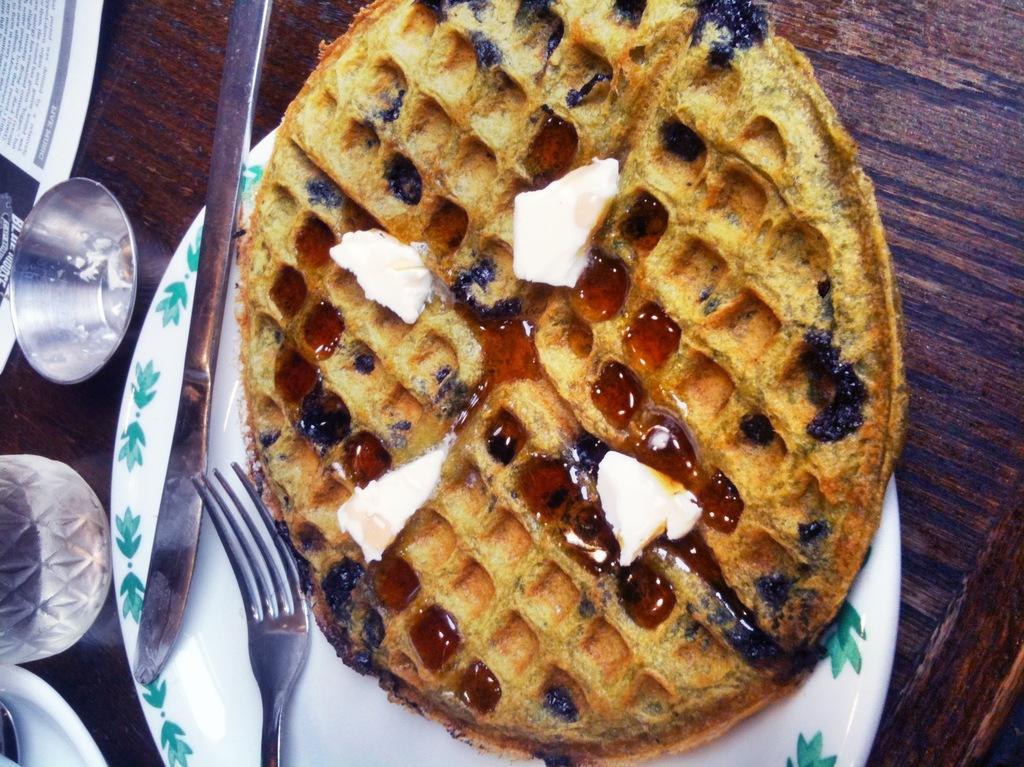Could you give a brief overview of what you see in this image? In the center of the image we can see a plate which has a waffle, fork and knife. On the left side of the image we can see glass and a bowl. 